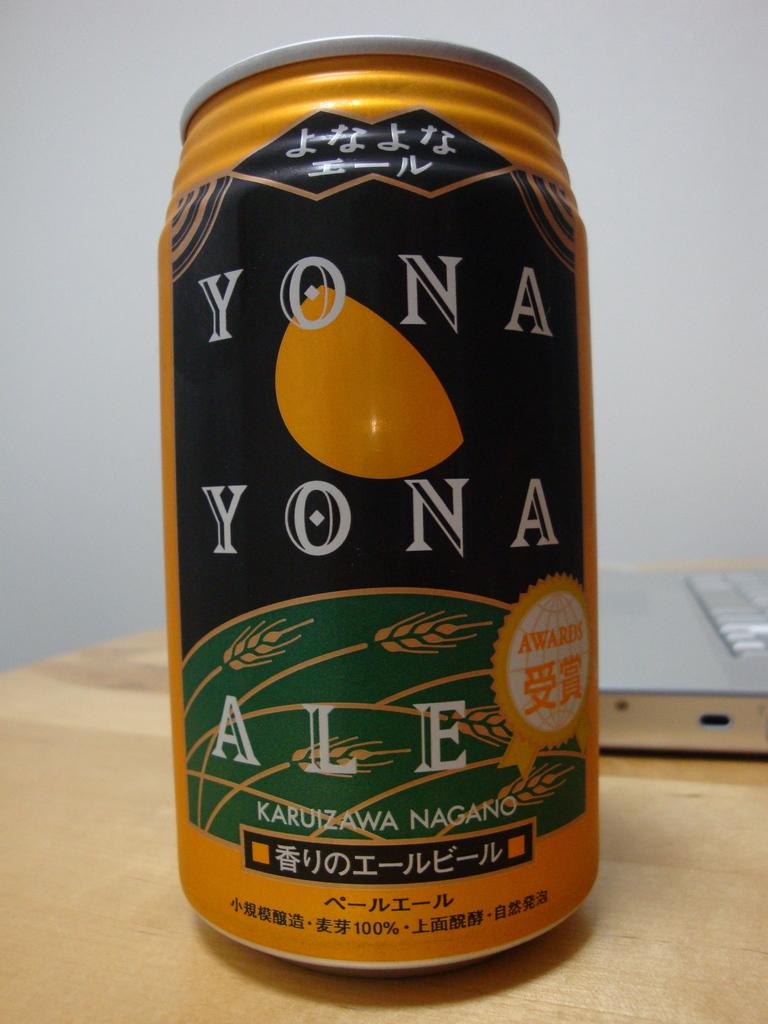<image>
Summarize the visual content of the image. A can of Yona Yona Ale from Nagano sits on a desk. 